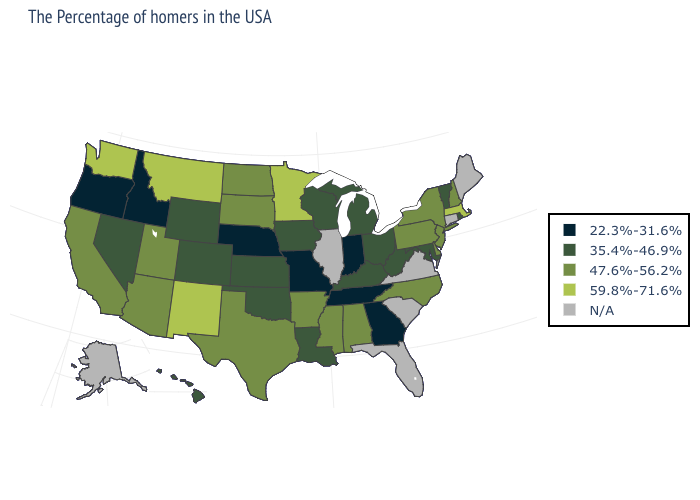What is the value of Hawaii?
Concise answer only. 35.4%-46.9%. Among the states that border West Virginia , does Kentucky have the lowest value?
Concise answer only. Yes. Among the states that border New Jersey , which have the lowest value?
Quick response, please. New York, Delaware, Pennsylvania. Does Kentucky have the highest value in the USA?
Answer briefly. No. Name the states that have a value in the range 47.6%-56.2%?
Concise answer only. New Hampshire, New York, New Jersey, Delaware, Pennsylvania, North Carolina, Alabama, Mississippi, Arkansas, Texas, South Dakota, North Dakota, Utah, Arizona, California. What is the lowest value in the MidWest?
Be succinct. 22.3%-31.6%. What is the value of Georgia?
Write a very short answer. 22.3%-31.6%. Name the states that have a value in the range N/A?
Keep it brief. Maine, Connecticut, Virginia, South Carolina, Florida, Illinois, Alaska. Name the states that have a value in the range 35.4%-46.9%?
Keep it brief. Rhode Island, Vermont, Maryland, West Virginia, Ohio, Michigan, Kentucky, Wisconsin, Louisiana, Iowa, Kansas, Oklahoma, Wyoming, Colorado, Nevada, Hawaii. What is the highest value in the USA?
Concise answer only. 59.8%-71.6%. Name the states that have a value in the range 47.6%-56.2%?
Short answer required. New Hampshire, New York, New Jersey, Delaware, Pennsylvania, North Carolina, Alabama, Mississippi, Arkansas, Texas, South Dakota, North Dakota, Utah, Arizona, California. Name the states that have a value in the range N/A?
Short answer required. Maine, Connecticut, Virginia, South Carolina, Florida, Illinois, Alaska. Does Nevada have the highest value in the USA?
Quick response, please. No. What is the value of North Dakota?
Be succinct. 47.6%-56.2%. 